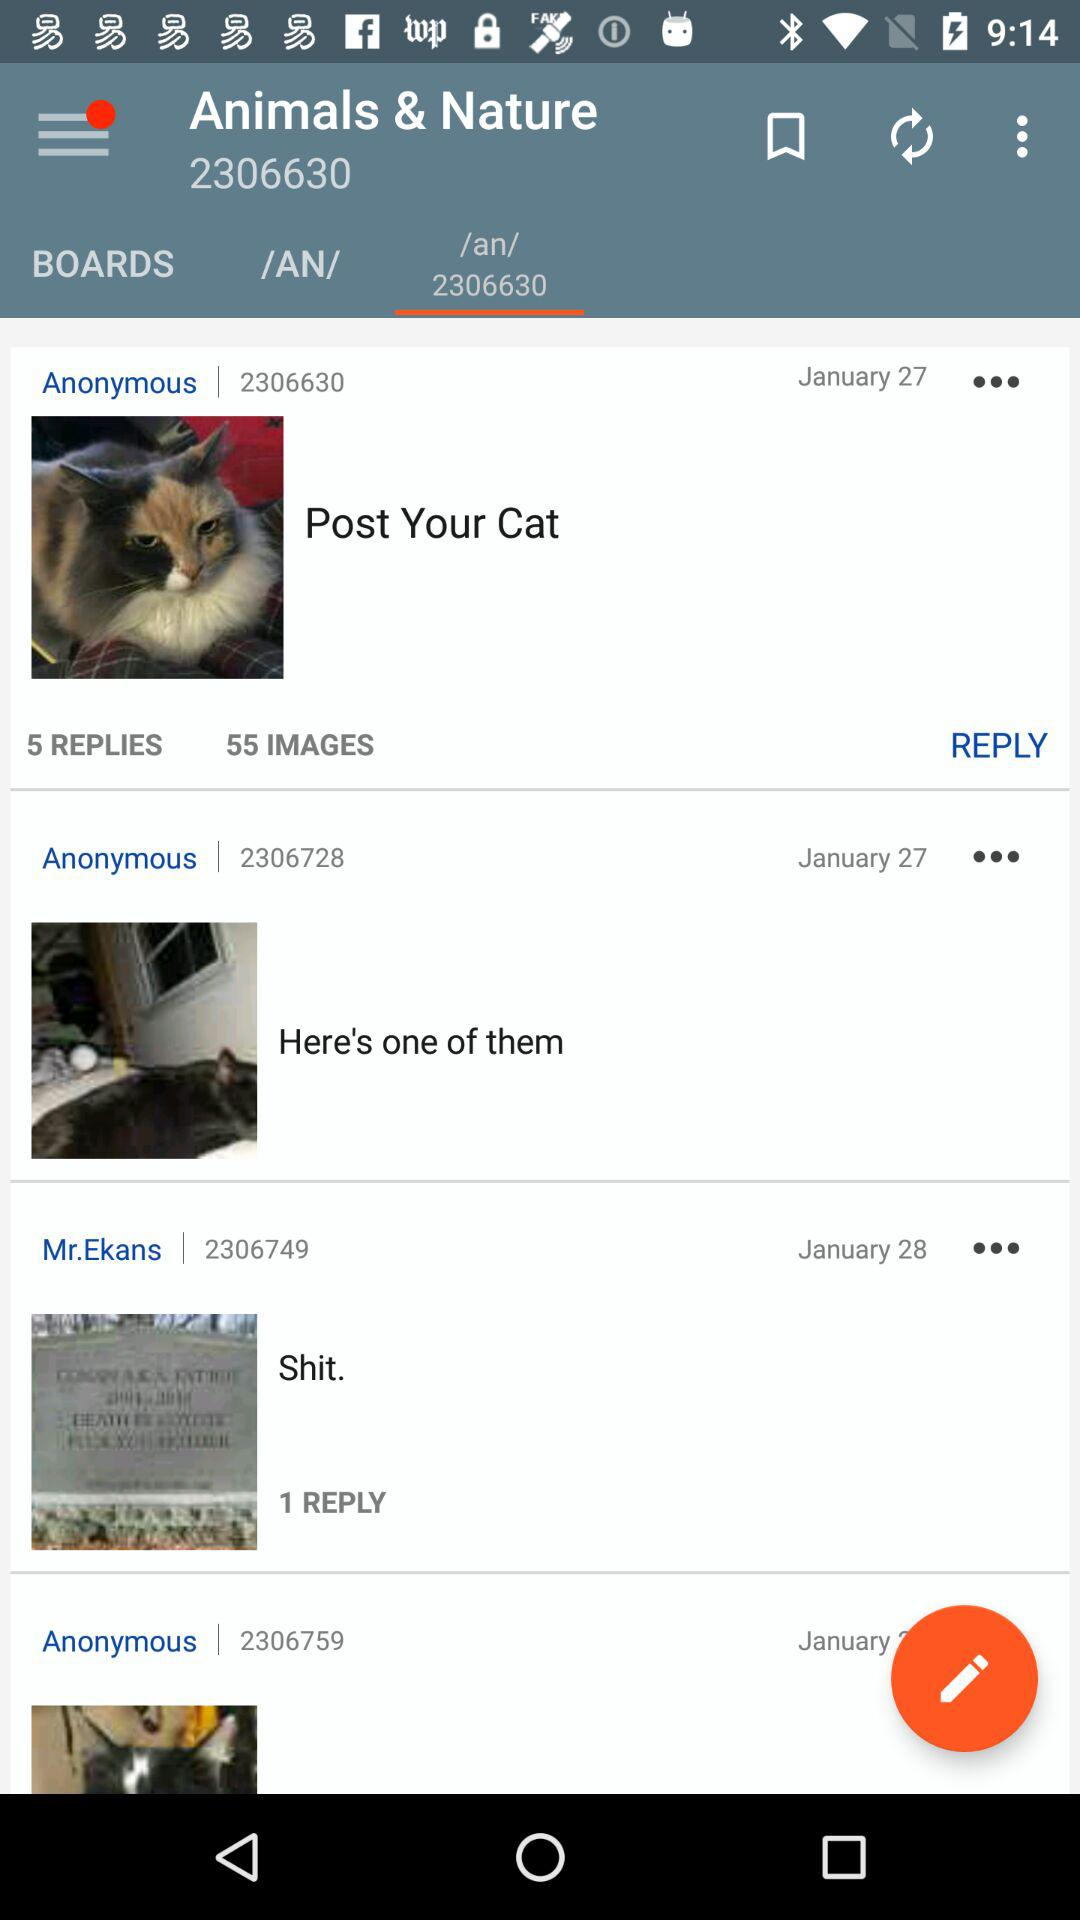How many replies are there on the post "Post Your Cat"? There are 5 replies. 